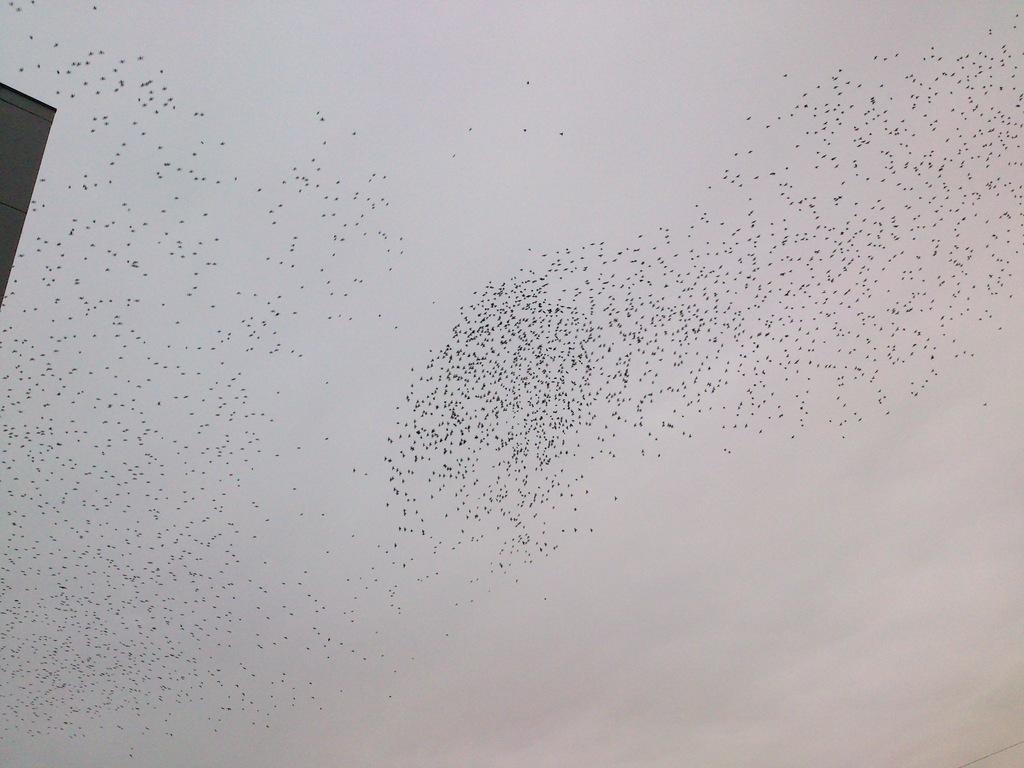What is the main subject of the image? The main subject of the image is a flock of birds. Where are the birds located in the image? The birds are in the sky. What type of leather is being used to write on the plane in the image? There is no plane or leather present in the image; it features a flock of birds in the sky. 